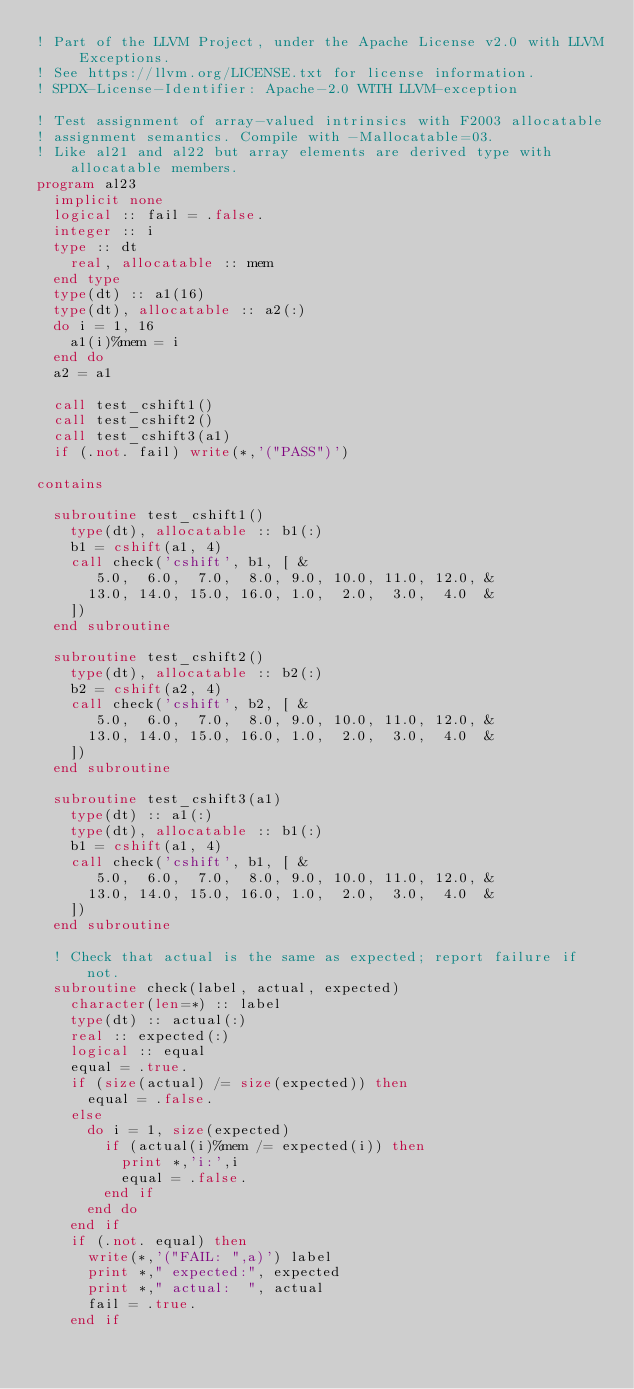<code> <loc_0><loc_0><loc_500><loc_500><_FORTRAN_>! Part of the LLVM Project, under the Apache License v2.0 with LLVM Exceptions.
! See https://llvm.org/LICENSE.txt for license information.
! SPDX-License-Identifier: Apache-2.0 WITH LLVM-exception

! Test assignment of array-valued intrinsics with F2003 allocatable
! assignment semantics. Compile with -Mallocatable=03.
! Like al21 and al22 but array elements are derived type with allocatable members.
program al23
  implicit none
  logical :: fail = .false.
  integer :: i
  type :: dt
    real, allocatable :: mem
  end type
  type(dt) :: a1(16)
  type(dt), allocatable :: a2(:)
  do i = 1, 16
    a1(i)%mem = i
  end do
  a2 = a1

  call test_cshift1()
  call test_cshift2()
  call test_cshift3(a1)
  if (.not. fail) write(*,'("PASS")')

contains

  subroutine test_cshift1()
    type(dt), allocatable :: b1(:)
    b1 = cshift(a1, 4)
    call check('cshift', b1, [ &
       5.0,  6.0,  7.0,  8.0, 9.0, 10.0, 11.0, 12.0, &
      13.0, 14.0, 15.0, 16.0, 1.0,  2.0,  3.0,  4.0  &
    ])
  end subroutine

  subroutine test_cshift2()
    type(dt), allocatable :: b2(:)
    b2 = cshift(a2, 4)
    call check('cshift', b2, [ &
       5.0,  6.0,  7.0,  8.0, 9.0, 10.0, 11.0, 12.0, &
      13.0, 14.0, 15.0, 16.0, 1.0,  2.0,  3.0,  4.0  &
    ])
  end subroutine

  subroutine test_cshift3(a1)
    type(dt) :: a1(:)
    type(dt), allocatable :: b1(:)
    b1 = cshift(a1, 4)
    call check('cshift', b1, [ &
       5.0,  6.0,  7.0,  8.0, 9.0, 10.0, 11.0, 12.0, &
      13.0, 14.0, 15.0, 16.0, 1.0,  2.0,  3.0,  4.0  &
    ])
  end subroutine

  ! Check that actual is the same as expected; report failure if not.
  subroutine check(label, actual, expected)
    character(len=*) :: label
    type(dt) :: actual(:)
    real :: expected(:)
    logical :: equal
    equal = .true.
    if (size(actual) /= size(expected)) then
      equal = .false.
    else
      do i = 1, size(expected)
        if (actual(i)%mem /= expected(i)) then
          print *,'i:',i
          equal = .false.
        end if
      end do
    end if
    if (.not. equal) then
      write(*,'("FAIL: ",a)') label
      print *," expected:", expected
      print *," actual:  ", actual
      fail = .true.
    end if</code> 